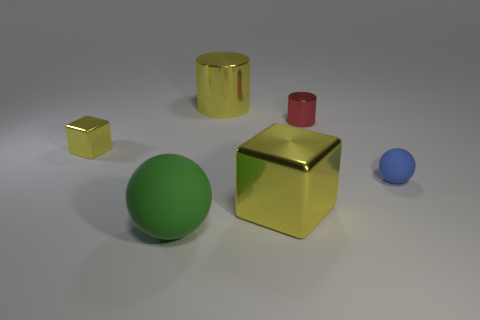Add 4 yellow metal objects. How many objects exist? 10 Add 4 metallic blocks. How many metallic blocks exist? 6 Subtract all blue balls. How many balls are left? 1 Subtract 0 yellow balls. How many objects are left? 6 Subtract all spheres. How many objects are left? 4 Subtract all red cylinders. Subtract all cyan balls. How many cylinders are left? 1 Subtract all green balls. How many gray cylinders are left? 0 Subtract all large cyan rubber cylinders. Subtract all small red metallic things. How many objects are left? 5 Add 4 blue matte spheres. How many blue matte spheres are left? 5 